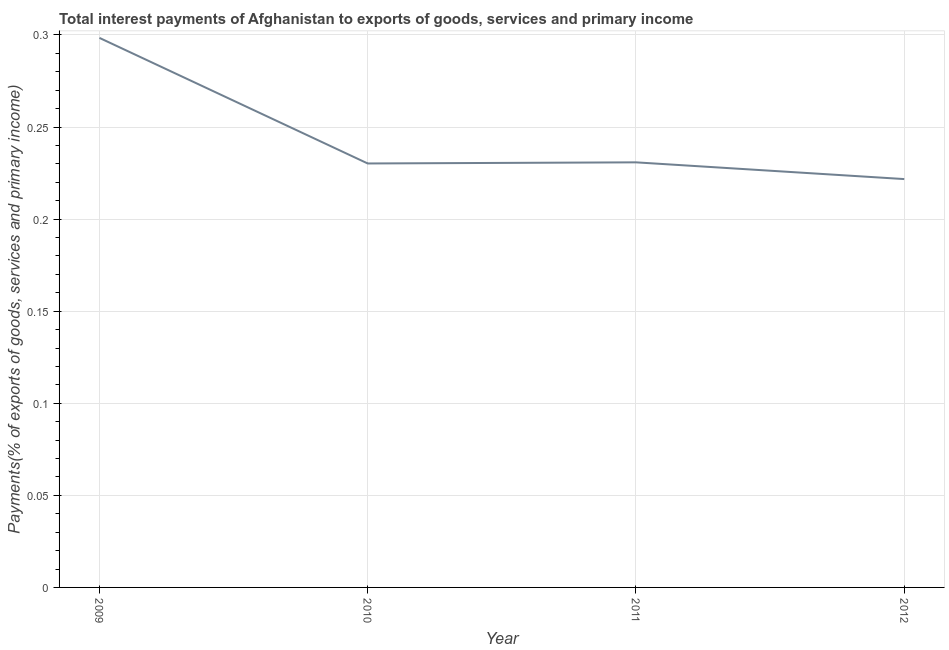What is the total interest payments on external debt in 2010?
Provide a succinct answer. 0.23. Across all years, what is the maximum total interest payments on external debt?
Ensure brevity in your answer.  0.3. Across all years, what is the minimum total interest payments on external debt?
Ensure brevity in your answer.  0.22. In which year was the total interest payments on external debt maximum?
Keep it short and to the point. 2009. What is the sum of the total interest payments on external debt?
Your answer should be very brief. 0.98. What is the difference between the total interest payments on external debt in 2009 and 2010?
Provide a succinct answer. 0.07. What is the average total interest payments on external debt per year?
Your answer should be very brief. 0.25. What is the median total interest payments on external debt?
Offer a very short reply. 0.23. In how many years, is the total interest payments on external debt greater than 0.28 %?
Ensure brevity in your answer.  1. What is the ratio of the total interest payments on external debt in 2010 to that in 2012?
Ensure brevity in your answer.  1.04. Is the total interest payments on external debt in 2011 less than that in 2012?
Make the answer very short. No. What is the difference between the highest and the second highest total interest payments on external debt?
Offer a terse response. 0.07. Is the sum of the total interest payments on external debt in 2009 and 2010 greater than the maximum total interest payments on external debt across all years?
Your answer should be compact. Yes. What is the difference between the highest and the lowest total interest payments on external debt?
Provide a succinct answer. 0.08. How many years are there in the graph?
Ensure brevity in your answer.  4. What is the difference between two consecutive major ticks on the Y-axis?
Offer a terse response. 0.05. Does the graph contain grids?
Your answer should be very brief. Yes. What is the title of the graph?
Your response must be concise. Total interest payments of Afghanistan to exports of goods, services and primary income. What is the label or title of the Y-axis?
Make the answer very short. Payments(% of exports of goods, services and primary income). What is the Payments(% of exports of goods, services and primary income) in 2009?
Provide a succinct answer. 0.3. What is the Payments(% of exports of goods, services and primary income) of 2010?
Provide a short and direct response. 0.23. What is the Payments(% of exports of goods, services and primary income) in 2011?
Give a very brief answer. 0.23. What is the Payments(% of exports of goods, services and primary income) in 2012?
Your response must be concise. 0.22. What is the difference between the Payments(% of exports of goods, services and primary income) in 2009 and 2010?
Provide a succinct answer. 0.07. What is the difference between the Payments(% of exports of goods, services and primary income) in 2009 and 2011?
Offer a very short reply. 0.07. What is the difference between the Payments(% of exports of goods, services and primary income) in 2009 and 2012?
Your answer should be compact. 0.08. What is the difference between the Payments(% of exports of goods, services and primary income) in 2010 and 2011?
Provide a succinct answer. -0. What is the difference between the Payments(% of exports of goods, services and primary income) in 2010 and 2012?
Your response must be concise. 0.01. What is the difference between the Payments(% of exports of goods, services and primary income) in 2011 and 2012?
Give a very brief answer. 0.01. What is the ratio of the Payments(% of exports of goods, services and primary income) in 2009 to that in 2010?
Give a very brief answer. 1.3. What is the ratio of the Payments(% of exports of goods, services and primary income) in 2009 to that in 2011?
Keep it short and to the point. 1.29. What is the ratio of the Payments(% of exports of goods, services and primary income) in 2009 to that in 2012?
Provide a succinct answer. 1.35. What is the ratio of the Payments(% of exports of goods, services and primary income) in 2010 to that in 2012?
Make the answer very short. 1.04. What is the ratio of the Payments(% of exports of goods, services and primary income) in 2011 to that in 2012?
Provide a short and direct response. 1.04. 